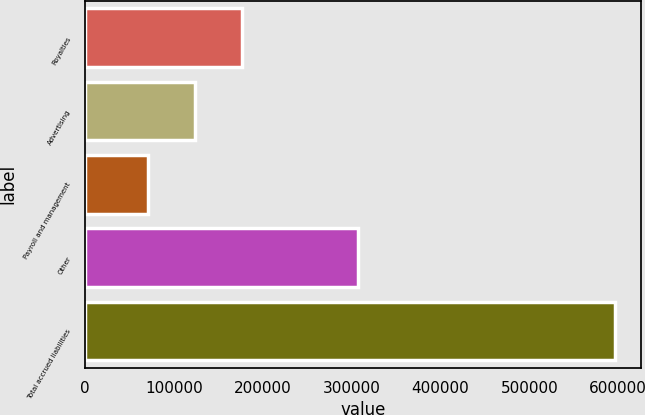Convert chart. <chart><loc_0><loc_0><loc_500><loc_500><bar_chart><fcel>Royalties<fcel>Advertising<fcel>Payroll and management<fcel>Other<fcel>Total accrued liabilities<nl><fcel>175996<fcel>123475<fcel>70954<fcel>306800<fcel>596164<nl></chart> 